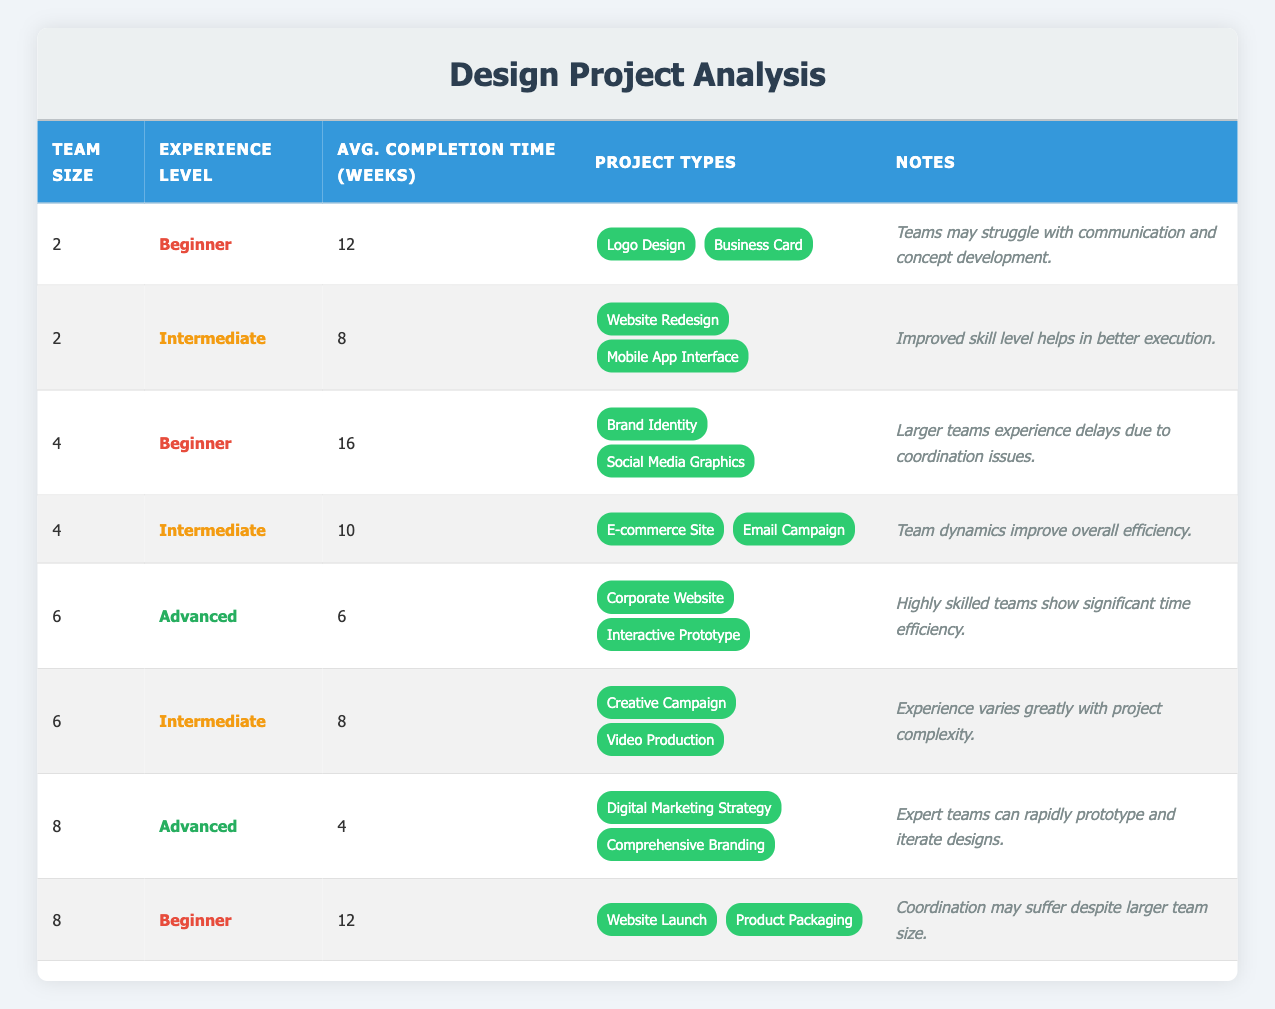What is the average completion time for teams of size 2? There are two entries for team size 2: one with 12 weeks for beginners and another with 8 weeks for intermediates. To find the average, we sum the times: 12 + 8 = 20 weeks, and then divide by 2, giving us an average of 20 / 2 = 10 weeks.
Answer: 10 weeks Is a team size of 4 associated with faster completion times compared to a team size of 2? For a team size of 2, the average completion times are 12 weeks (beginner) and 8 weeks (intermediate) with an average of 10 weeks. For team size 4, the times are 16 weeks (beginner) and 10 weeks (intermediate) with an average of 13 weeks. Since 13 weeks (team size 4) is greater than 10 weeks (team size 2), the answer is no.
Answer: No Which experience level has the fastest average completion time with a team size of 8? There are two entries for team size 8: one for an advanced team with a completion time of 4 weeks and another for a beginner team with 12 weeks. The advanced team has the fastest time.
Answer: Advanced How much longer does a beginner team of size 4 take compared to an advanced team of size 6? The beginner team of size 4 takes 16 weeks while the advanced team of size 6 takes 6 weeks. The difference is 16 - 6 = 10 weeks, indicating the beginner team takes 10 weeks longer.
Answer: 10 weeks Are teams with advanced experience completing projects faster than those with intermediate experience? To check this, we look for both advanced and intermediate teams: Advanced teams have completion times of 4 weeks (size 8), 6 weeks (size 6); Intermediate teams have 8 weeks (size 2), 10 weeks (size 4), 8 weeks (size 6), and a 12 weeks (size 8). The fastest time for advanced is 4 weeks and the slowest for intermediate is 12 weeks, indicating that yes, advanced teams are completing projects faster.
Answer: Yes What is the average completion time for intermediate level teams across all team sizes? The intermediate teams have completion times of 8 weeks (size 2), 10 weeks (size 4), and 8 weeks (size 6). To find the average, sum these times: 8 + 10 + 8 = 26 weeks and then divide by 3, giving an average of 26 / 3 ≈ 8.67 weeks.
Answer: Approximately 8.67 weeks Is it true that larger teams (size 8) always have longer completion times? There are two data points for team size 8: one for an advanced team with 4 weeks and another for a beginner team with 12 weeks. Since the advanced team completes projects faster, it implies that larger teams do not always have longer times.
Answer: No 